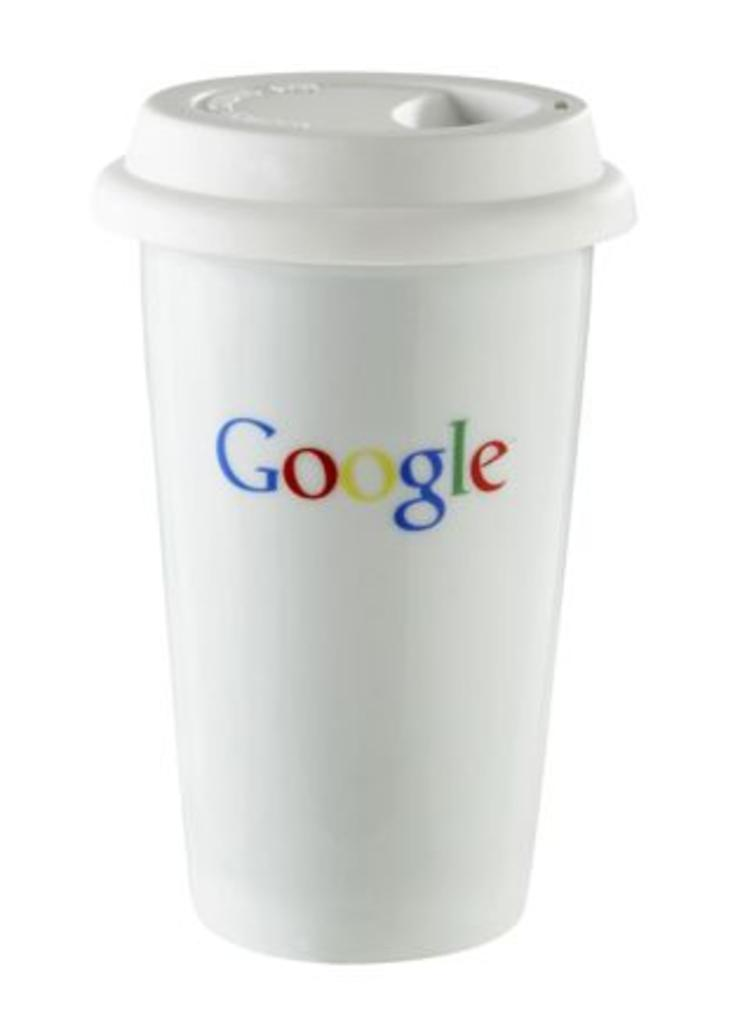<image>
Share a concise interpretation of the image provided. A white coffee cup with a lid has the Google logo on it. 